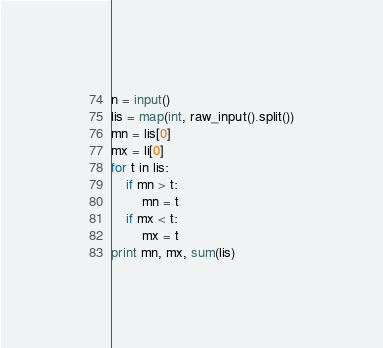Convert code to text. <code><loc_0><loc_0><loc_500><loc_500><_Python_>n = input()
lis = map(int, raw_input().split())
mn = lis[0]
mx = li[0]
for t in lis:
	if mn > t:
		mn = t
	if mx < t:
		mx = t
print mn, mx, sum(lis)</code> 